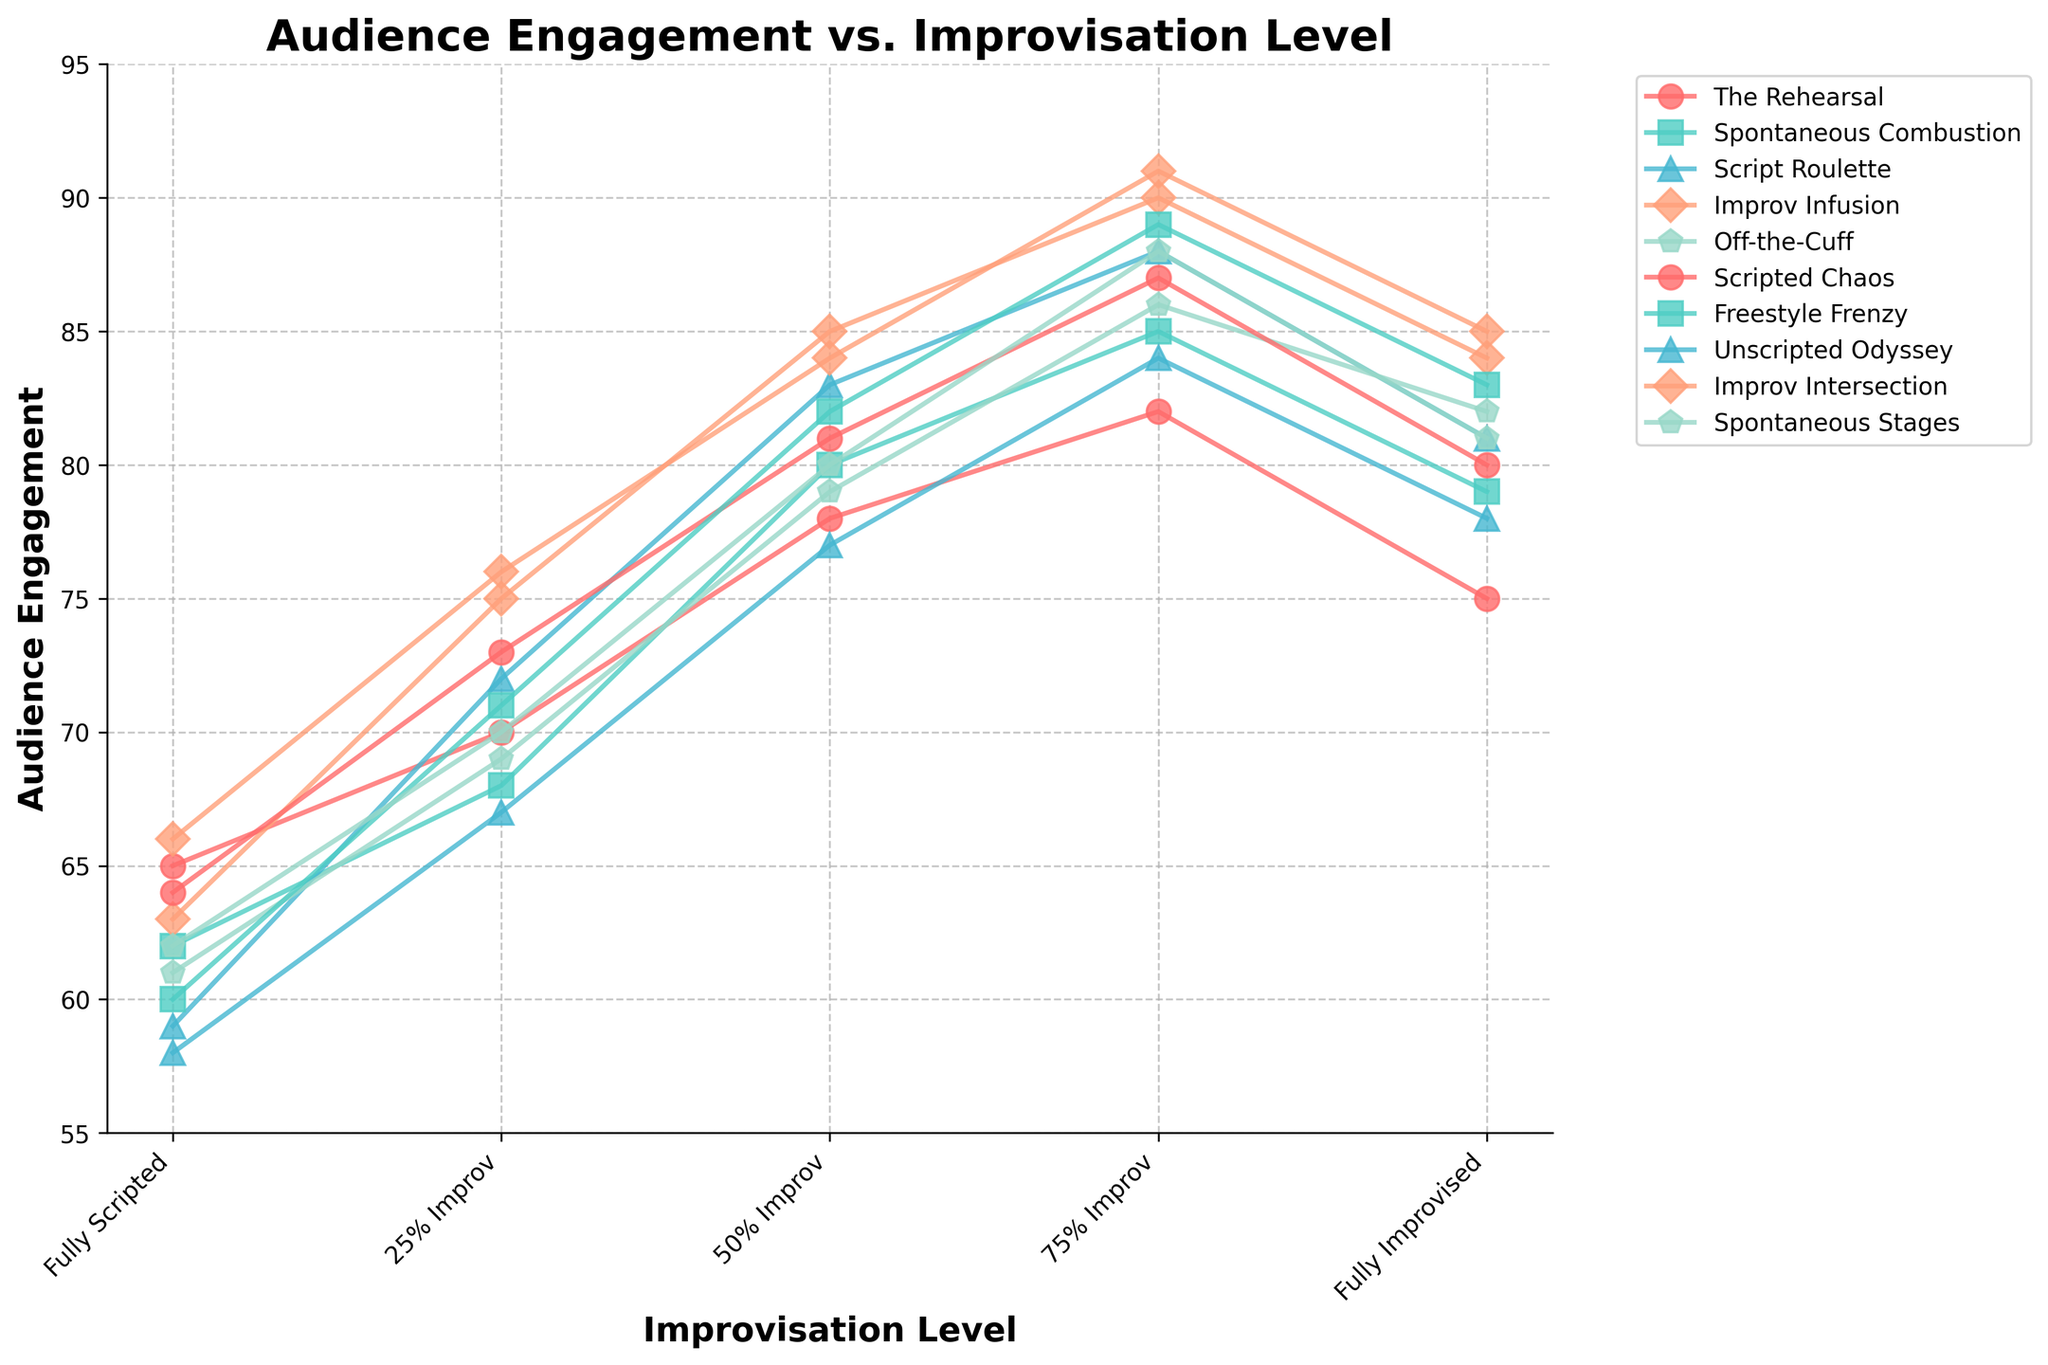What's the trend in audience engagement as improvisation levels increase from "Fully Scripted" to "Fully Improvised"? The line chart shows each show's audience engagement on the y-axis and different levels of improvisation on the x-axis. Generally, the lines show an upward trend, meaning that audience engagement tends to increase as improvisation levels rise from "Fully Scripted" to "75% Improv", but it slightly drops at "Fully Improvised".
Answer: Audience engagement increases until "75% Improv", then slightly drops at "Fully Improvised" Which show has the highest audience engagement at "75% Improv" level? To determine this, look at the points on the "75% Improv" level for each line representing a show. The show "Improv Intersection" has the highest engagement with a value of 91.
Answer: Improv Intersection How does the audience engagement of "Fully Scripted" compare to "Fully Improvised" across all shows? For comparison, observe the values at both "Fully Scripted" and "Fully Improvised" ends of each line. In all cases, engagement increases from "Fully Scripted" to "Fully Improvised", though the increase varies by show.
Answer: Fully Improvised is higher Which shows have their highest audience engagement at "75% Improv"? Look at each show's engagement values and identify the highest point. The shows "The Rehearsal", "Script Roulette", "Improv Infusion", "Off-the-Cuff", "Scripted Chaos", "Freestyle Frenzy", and "Improv Intersection" reach their peak at "75% Improv".
Answer: Multiple shows What is the average audience engagement at the "50% Improv" level? Add the engagement values at "50% Improv" for all shows and divide by the number of shows. (78+80+83+85+79+81+82+77+84+80)/10 = 80.9
Answer: 80.9 Which color represents the show "Spontaneous Stages" and how is its audience engagement at "25% Improv" level compared to "Fully Scripted"? Find the color corresponding to "Spontaneous Stages" line and compare its values at "25% Improv" and "Fully Scripted". The color is the fourth unique one and engagement increases from 62 to 70.
Answer: Fourth color, increases Is there any show where the engagement decreases when moving from "50% Improv" to "75% Improv"? Check each show's audience engagement value from "50% Improv" to "75% Improv". In all cases, the engagement increases when moving from "50% Improv" to "75% Improv".
Answer: No What's the difference in audience engagement between "The Rehearsal" and "Unscripted Odyssey" at "75% Improv" level? Subtract the "75% Improv" value of "Unscripted Odyssey" from "The Rehearsal". The values are 82 and 84 respectively. The difference is 82 - 84 = -2.
Answer: -2 Among the top three shows with highest audience engagement at "Fully Improvised", what is the engagement range (difference between highest and lowest)? Identify the three shows with highest engagements at "Fully Improvised", which are "Improv Intersection" (85), "Improv Infusion" (84), and "Freestyle Frenzy" (83). Subtract the lowest engagement from the highest: 85 - 83 = 2.
Answer: 2 